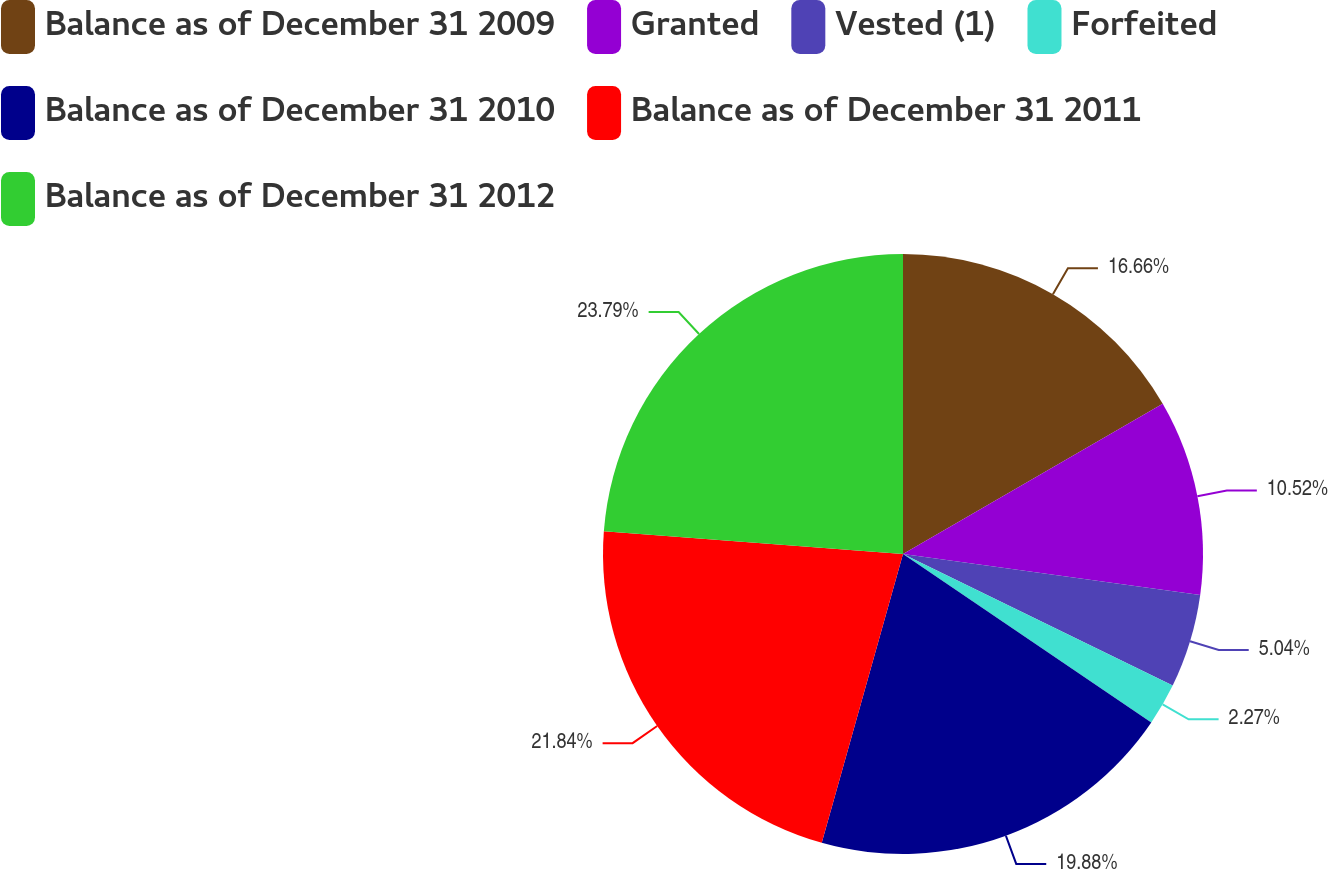<chart> <loc_0><loc_0><loc_500><loc_500><pie_chart><fcel>Balance as of December 31 2009<fcel>Granted<fcel>Vested (1)<fcel>Forfeited<fcel>Balance as of December 31 2010<fcel>Balance as of December 31 2011<fcel>Balance as of December 31 2012<nl><fcel>16.66%<fcel>10.52%<fcel>5.04%<fcel>2.27%<fcel>19.88%<fcel>21.84%<fcel>23.8%<nl></chart> 